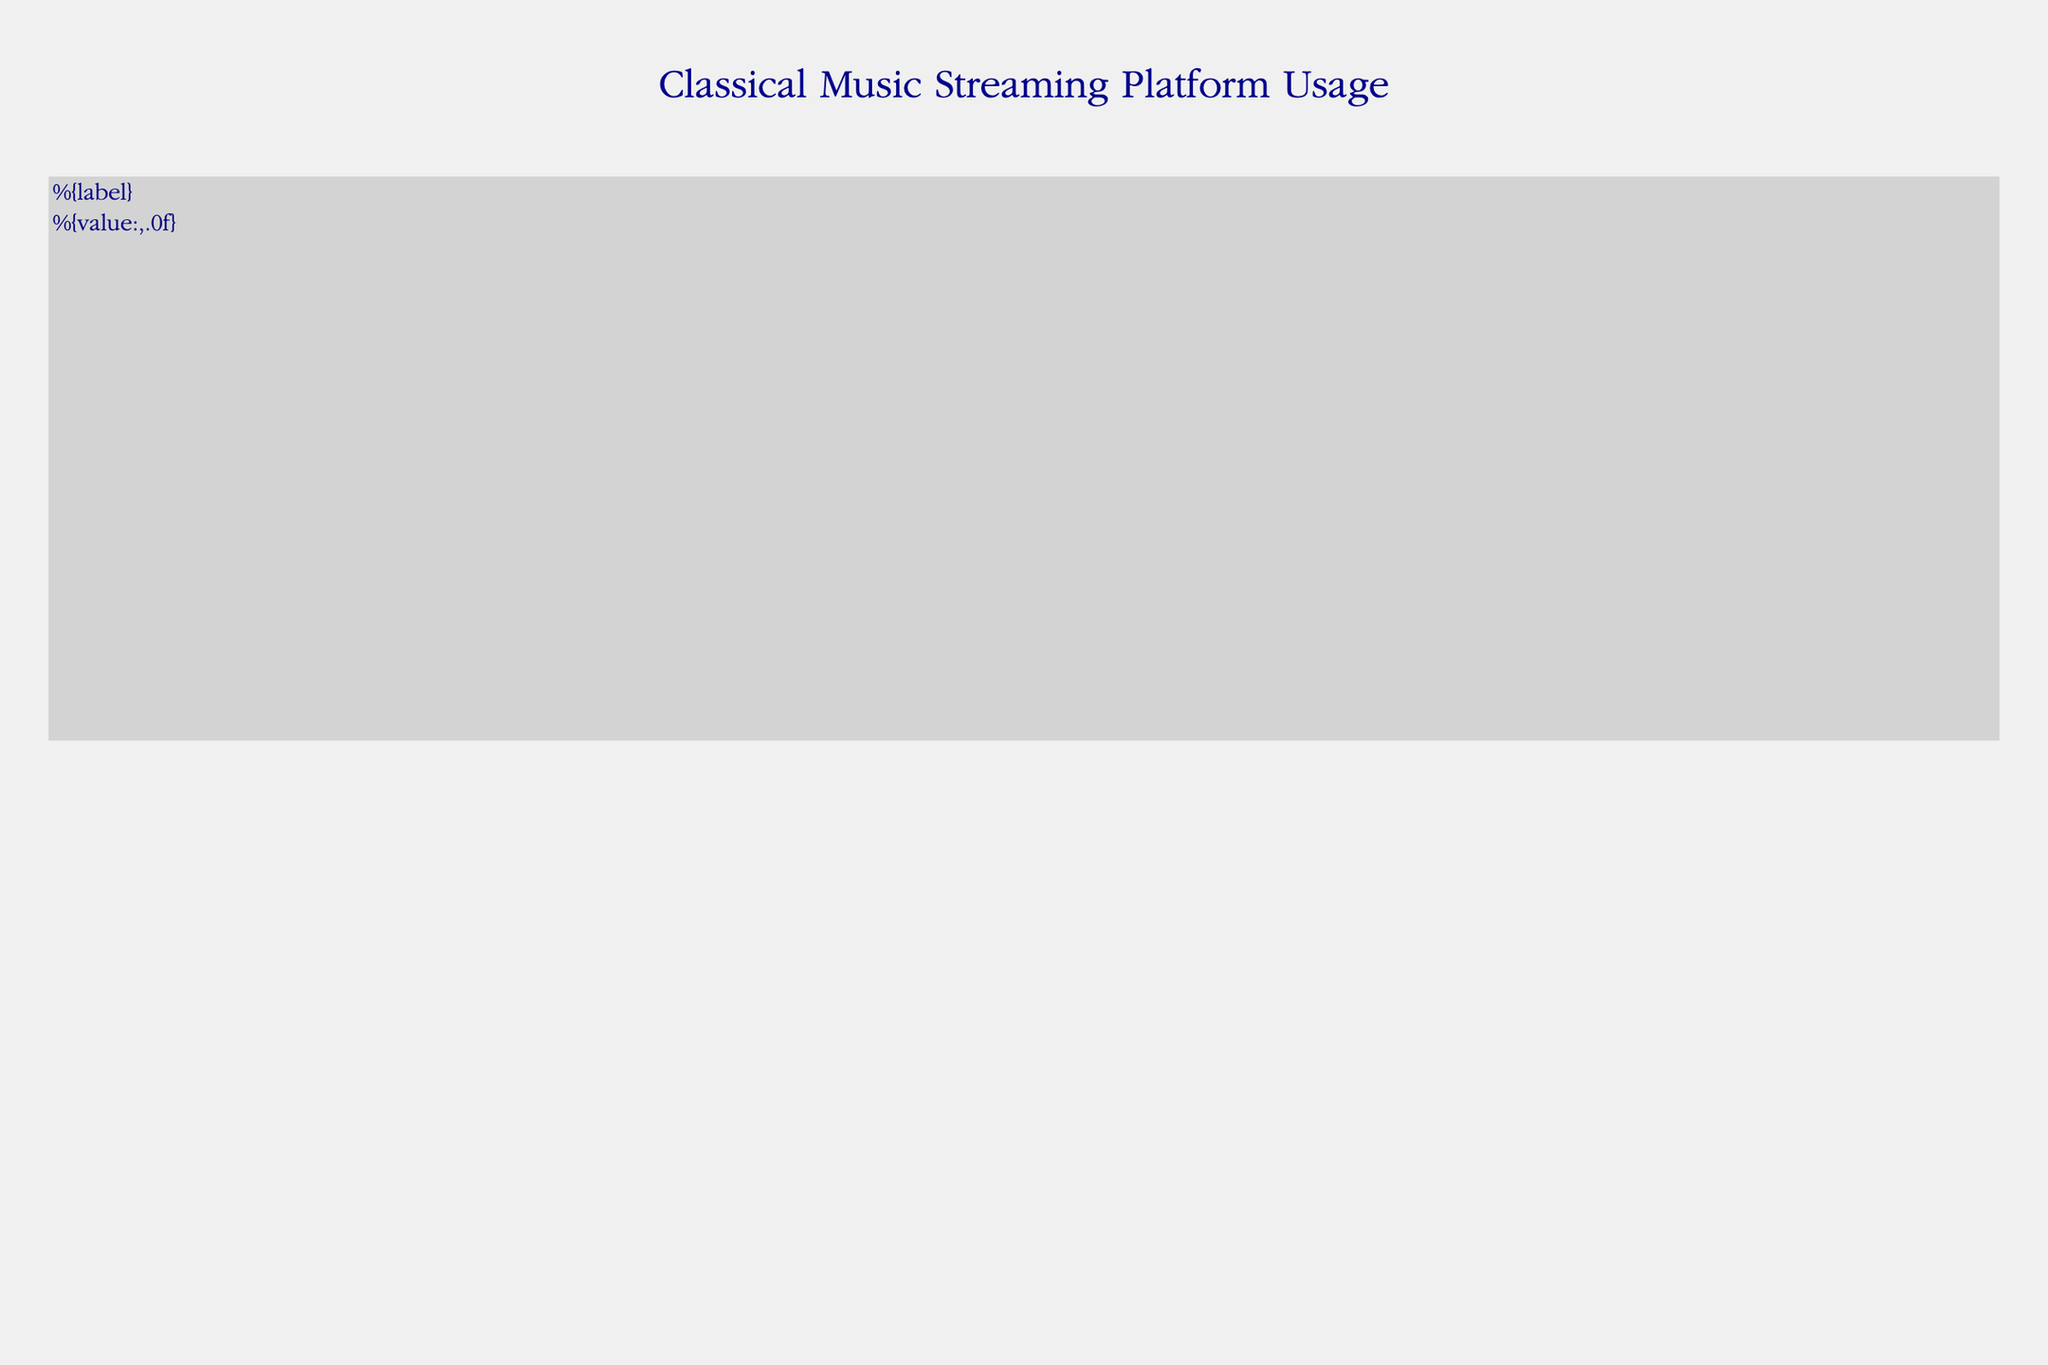What's the title of the figure? The title is prominently displayed at the top of the figure in a larger and bolded font size.
Answer: Classical Music Streaming Platform Usage Which orchestra has the highest popularity? In the "Popularity" category under the "High" subcategory, the Vienna Philharmonic has the largest value.
Answer: Vienna Philharmonic What is the total number of listeners in the "Demographics" category? Add up the listeners from all subcategories in "Demographics": 1500000 (18-30) + 2800000 (31-50) + 3200000 (51+) + 3700000 (Male) + 3800000 (Female) = 15,000,000
Answer: 15,000,000 Which gender has more listeners in the "Demographics" category? Compare the values under the "Gender" subcategory. Since Female has 3800000 and Male has 3700000, females have more listeners.
Answer: Female How many more listeners are there for the London Symphony Orchestra compared to the Kronos Quartet? Subtract the listeners of the Kronos Quartet from the London Symphony Orchestra: 2000000 - 800000 = 1,200,000
Answer: 1,200,000 Which playlist era category has the fewest listeners? Under the "Playlists - Eras" subcategory, compare the values: Baroque (1200000), Classical (1800000), Romantic (2200000), 20th Century (1500000). The lowest value is for Baroque.
Answer: Baroque What is the most popular playlist category in terms of mood? Compare the values under "Playlists - Moods": Relaxing (2500000), Energetic (1200000), Melancholic (1000000). Relaxing has the highest value.
Answer: Relaxing Which age group has the highest number of listeners? Compare the values under "Demographics - Age": 18-30 (1500000), 31-50 (2800000), 51+ (3200000). The 51+ age group has the highest number of listeners.
Answer: 51+ What is the combined number of listeners for the Vienna Philharmonic and the Academy of St Martin in the Fields? Add the listeners of both orchestras: 2500000 (Vienna Philharmonic) + 1200000 (Academy of St Martin in the Fields) = 3,700,000
Answer: 3,700,000 Which playlist category by instrument has more listeners: Piano or Chamber? Compare the values under the "Playlists - Instruments" subcategory: Piano (1800000) and Chamber (1200000). Piano has more listeners.
Answer: Piano 